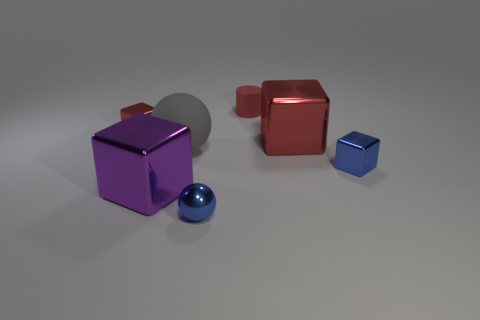How many red cubes must be subtracted to get 1 red cubes? 1 Subtract all brown blocks. Subtract all yellow cylinders. How many blocks are left? 4 Add 2 red shiny objects. How many objects exist? 9 Subtract all cylinders. How many objects are left? 6 Add 3 shiny blocks. How many shiny blocks exist? 7 Subtract 0 cyan blocks. How many objects are left? 7 Subtract all small red matte things. Subtract all purple metal objects. How many objects are left? 5 Add 6 tiny cubes. How many tiny cubes are left? 8 